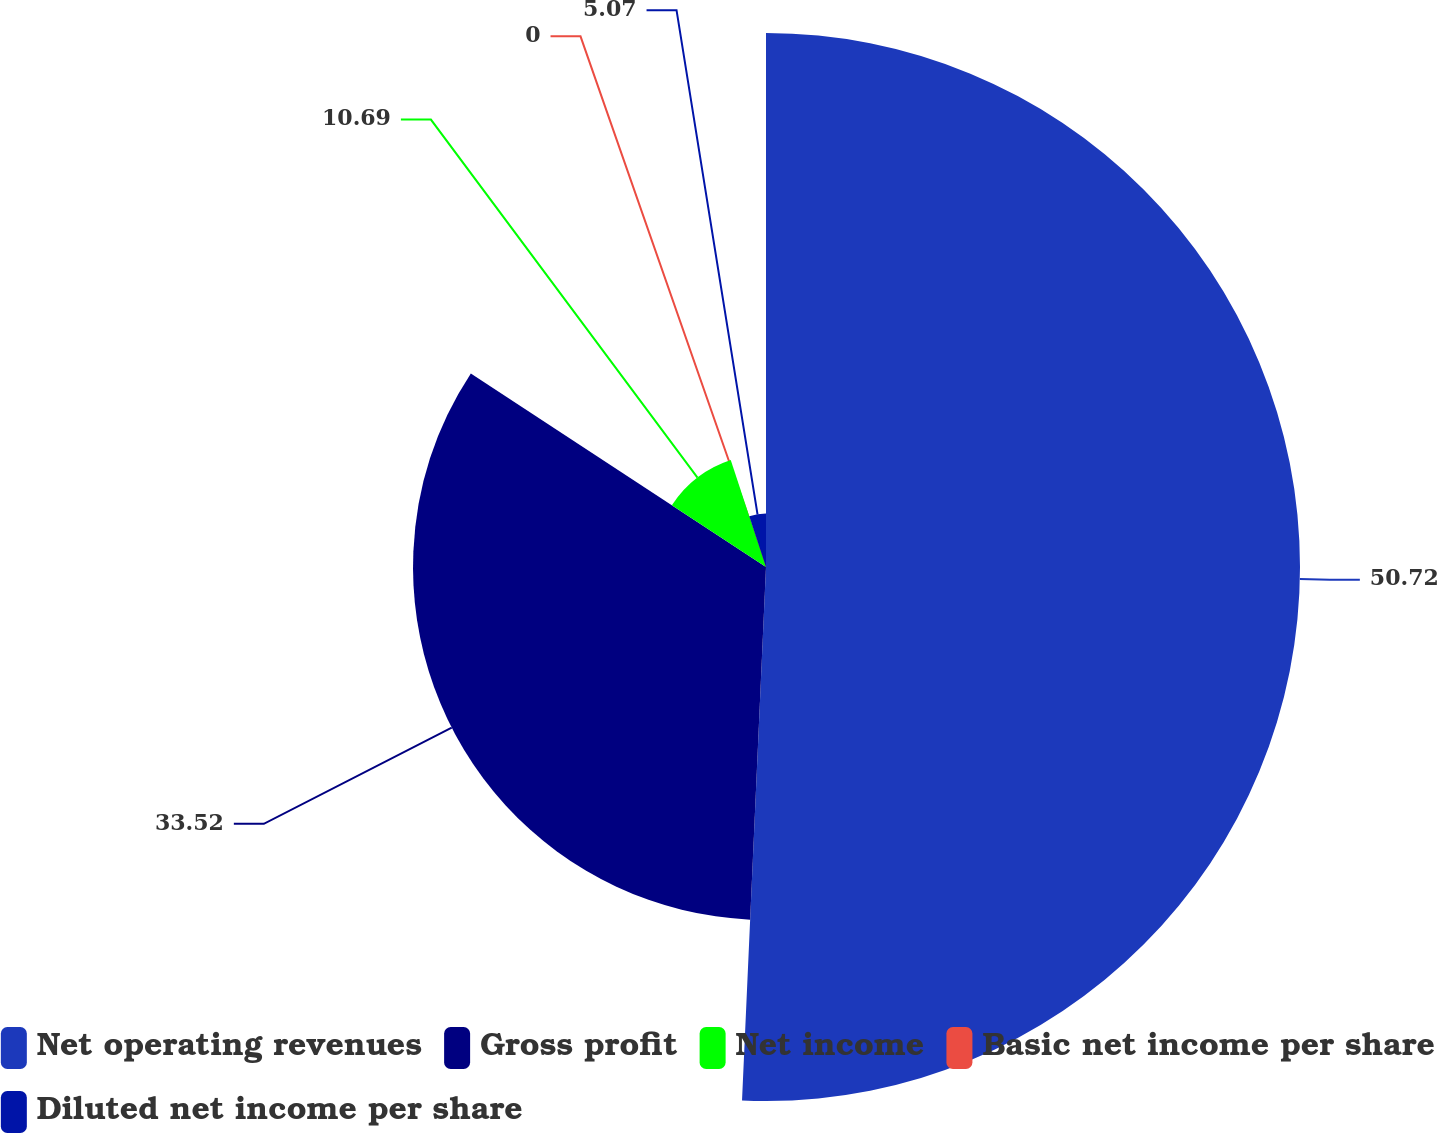Convert chart to OTSL. <chart><loc_0><loc_0><loc_500><loc_500><pie_chart><fcel>Net operating revenues<fcel>Gross profit<fcel>Net income<fcel>Basic net income per share<fcel>Diluted net income per share<nl><fcel>50.71%<fcel>33.52%<fcel>10.69%<fcel>0.0%<fcel>5.07%<nl></chart> 